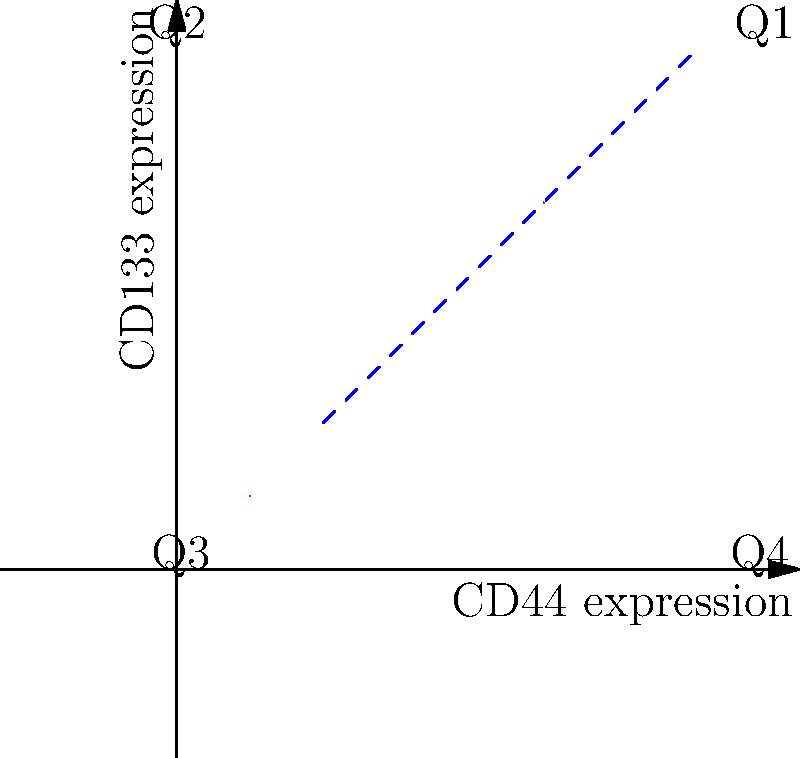Based on the flow cytometry plot showing CD44 and CD133 expression in a cancer cell population, which quadrant would most likely contain cancer stem cells, and what does the dashed blue line represent? To answer this question, we need to consider the following steps:

1. Understand the markers:
   CD44 and CD133 are common cancer stem cell markers in various types of cancer.

2. Interpret the plot:
   - The x-axis represents CD44 expression.
   - The y-axis represents CD133 expression.
   - The plot is divided into four quadrants (Q1, Q2, Q3, Q4).

3. Identify the quadrant with high expression of both markers:
   - Q1 (upper right) shows high expression of both CD44 and CD133.
   - Cancer stem cells typically express high levels of these markers.

4. Understand the significance of the dashed blue line:
   - The dashed blue line is a gate used to separate cell populations.
   - It divides the plot diagonally, isolating the cells in Q1.

5. Interpret the gate's purpose:
   - The gate is likely used to select or sort cells with high expression of both CD44 and CD133.
   - These cells are potential cancer stem cells.

Therefore, the cancer stem cells would most likely be found in Q1 (upper right quadrant), and the dashed blue line represents a gate for selecting or sorting these potential cancer stem cells based on their high expression of both CD44 and CD133.
Answer: Q1; sorting gate for potential cancer stem cells 